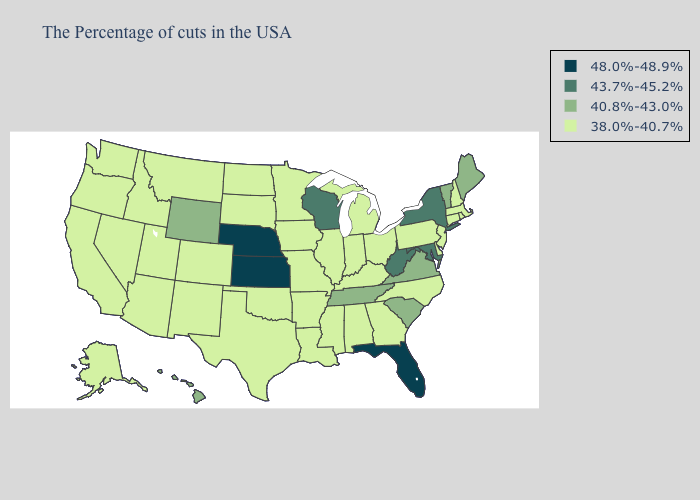Does Oklahoma have the highest value in the South?
Keep it brief. No. What is the value of Mississippi?
Quick response, please. 38.0%-40.7%. What is the highest value in states that border Pennsylvania?
Concise answer only. 43.7%-45.2%. What is the highest value in the MidWest ?
Give a very brief answer. 48.0%-48.9%. Does Indiana have the same value as Oklahoma?
Answer briefly. Yes. What is the value of Montana?
Quick response, please. 38.0%-40.7%. What is the lowest value in states that border New York?
Concise answer only. 38.0%-40.7%. Which states have the lowest value in the USA?
Short answer required. Massachusetts, Rhode Island, New Hampshire, Connecticut, New Jersey, Delaware, Pennsylvania, North Carolina, Ohio, Georgia, Michigan, Kentucky, Indiana, Alabama, Illinois, Mississippi, Louisiana, Missouri, Arkansas, Minnesota, Iowa, Oklahoma, Texas, South Dakota, North Dakota, Colorado, New Mexico, Utah, Montana, Arizona, Idaho, Nevada, California, Washington, Oregon, Alaska. Name the states that have a value in the range 43.7%-45.2%?
Short answer required. New York, Maryland, West Virginia, Wisconsin. Which states have the lowest value in the MidWest?
Be succinct. Ohio, Michigan, Indiana, Illinois, Missouri, Minnesota, Iowa, South Dakota, North Dakota. Which states have the lowest value in the South?
Give a very brief answer. Delaware, North Carolina, Georgia, Kentucky, Alabama, Mississippi, Louisiana, Arkansas, Oklahoma, Texas. Does the first symbol in the legend represent the smallest category?
Be succinct. No. Name the states that have a value in the range 40.8%-43.0%?
Short answer required. Maine, Vermont, Virginia, South Carolina, Tennessee, Wyoming, Hawaii. Does Tennessee have the lowest value in the South?
Keep it brief. No. Name the states that have a value in the range 43.7%-45.2%?
Concise answer only. New York, Maryland, West Virginia, Wisconsin. 